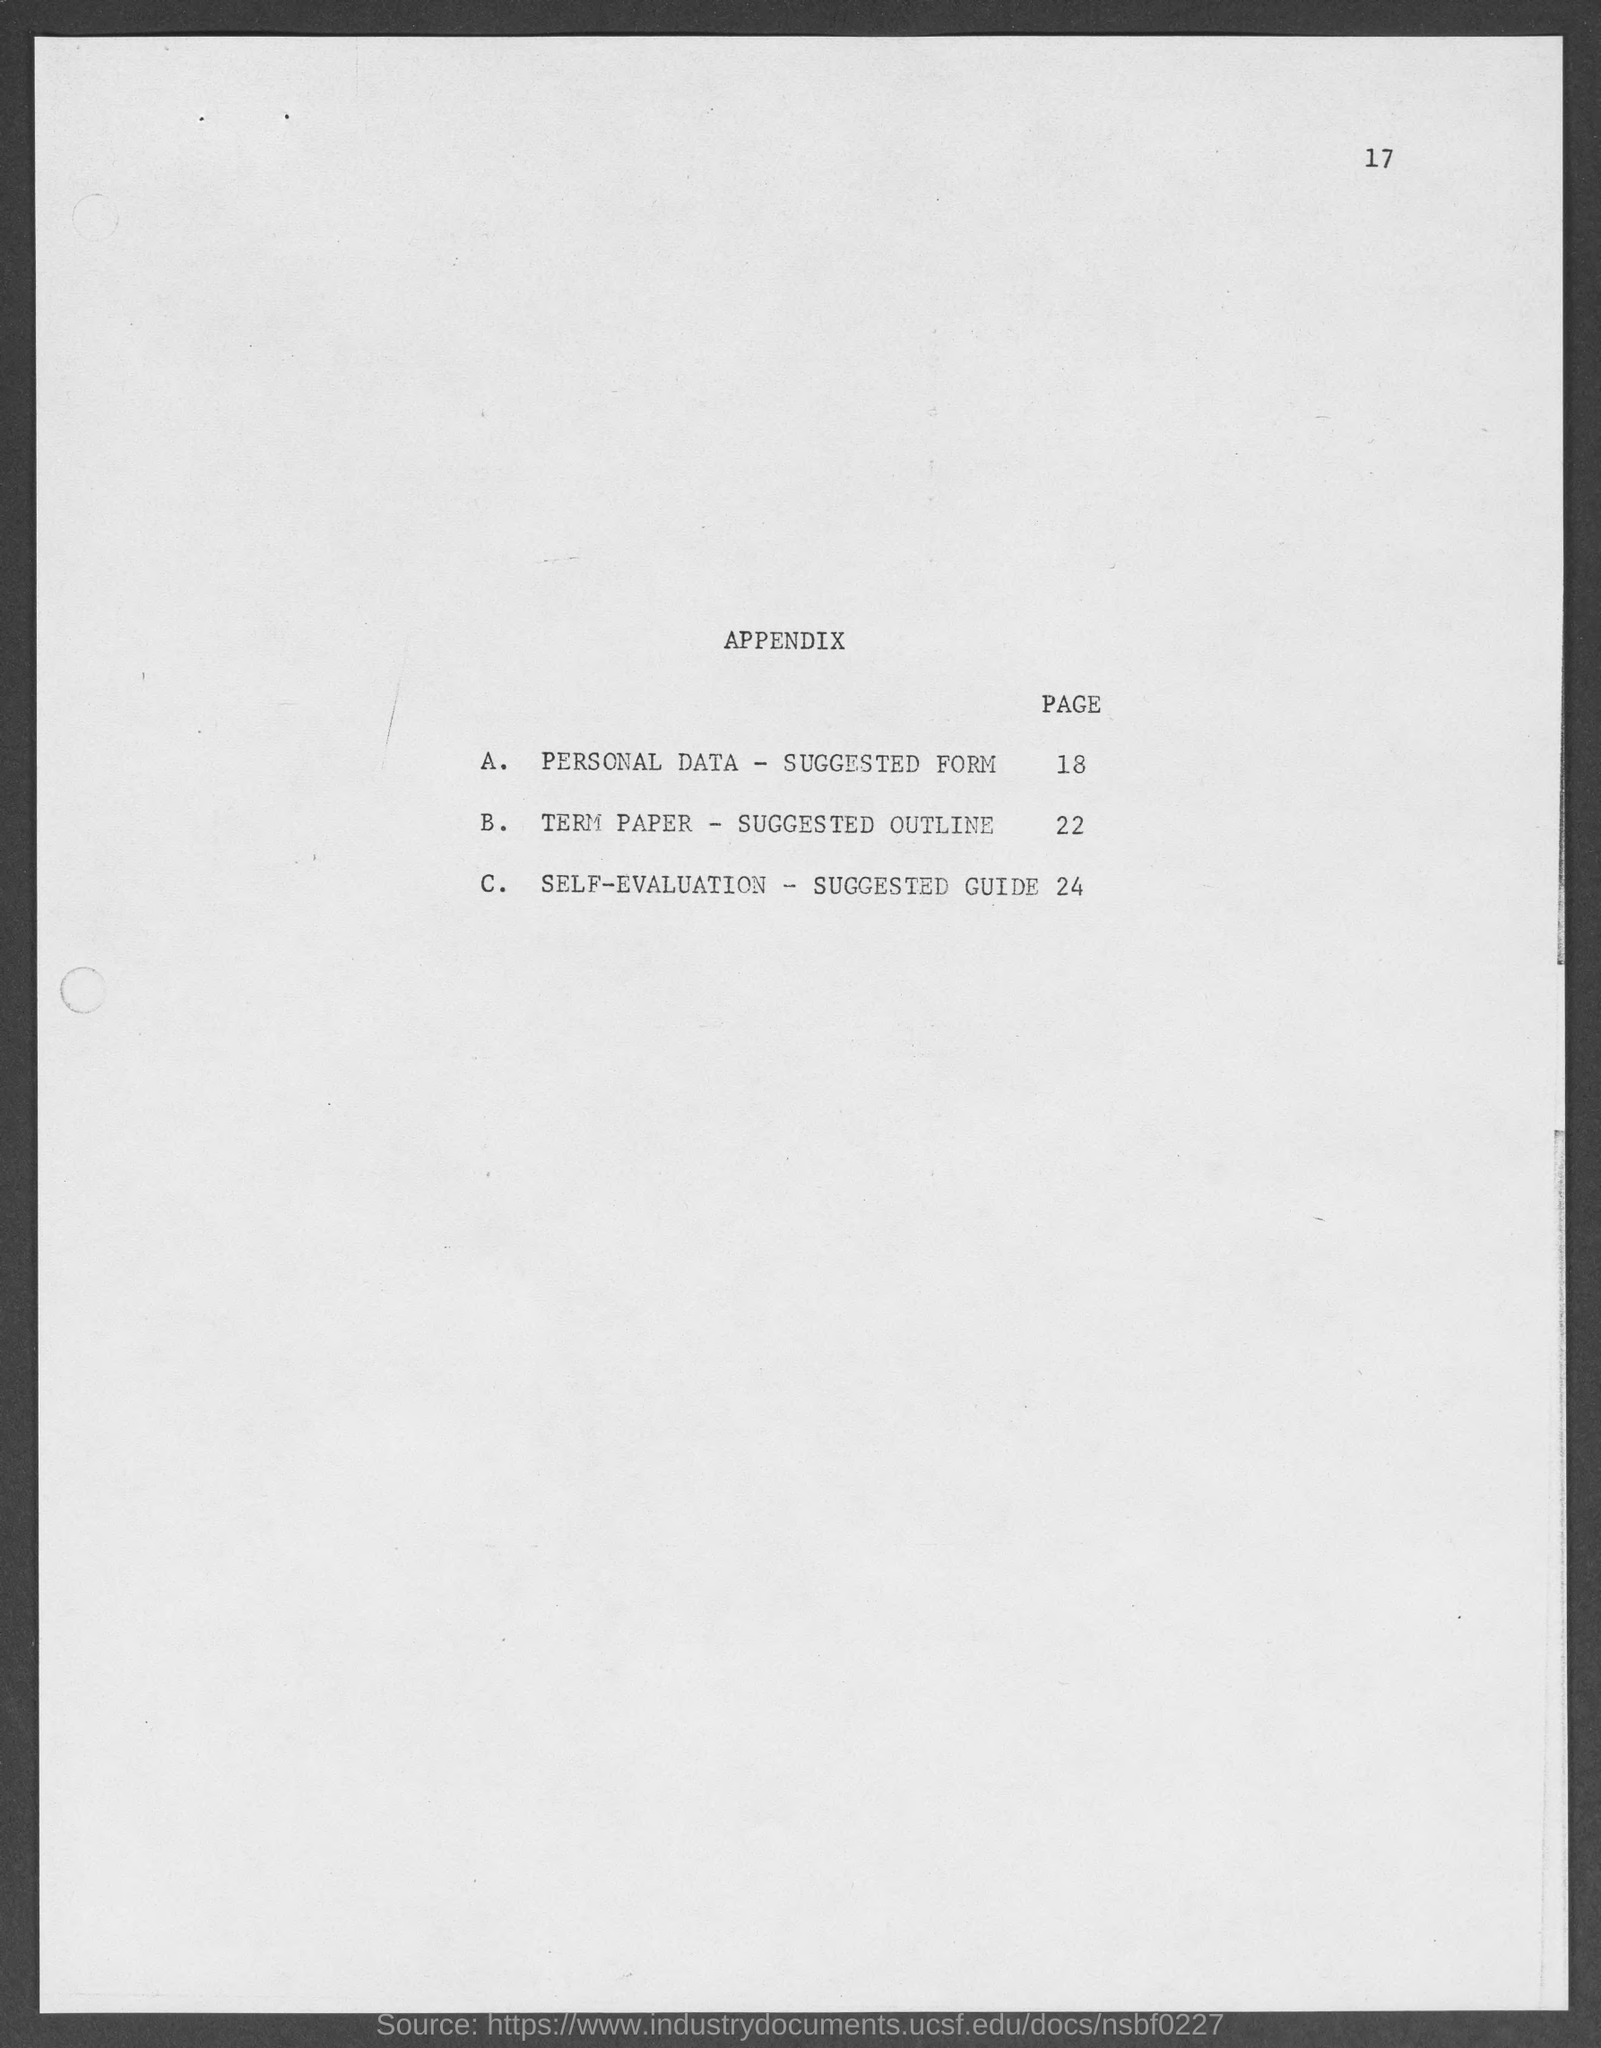What is the page number at top of the page?
Provide a succinct answer. 17. 